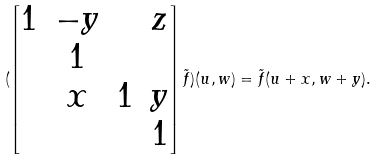<formula> <loc_0><loc_0><loc_500><loc_500>( \begin{bmatrix} 1 & - y & & z \\ & 1 & & \\ & x & 1 & y \\ & & & 1 \end{bmatrix} \tilde { f } ) ( u , w ) = \tilde { f } ( u + x , w + y ) .</formula> 